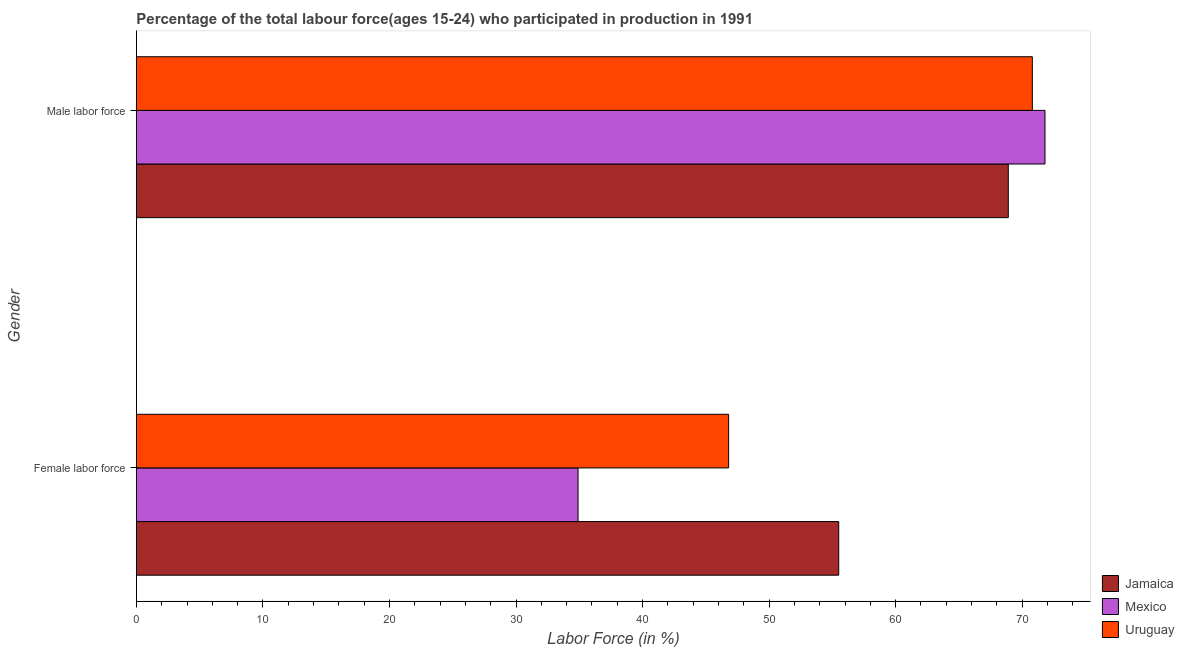Are the number of bars per tick equal to the number of legend labels?
Offer a very short reply. Yes. Are the number of bars on each tick of the Y-axis equal?
Your response must be concise. Yes. What is the label of the 2nd group of bars from the top?
Offer a terse response. Female labor force. What is the percentage of female labor force in Jamaica?
Provide a succinct answer. 55.5. Across all countries, what is the maximum percentage of female labor force?
Provide a succinct answer. 55.5. Across all countries, what is the minimum percentage of female labor force?
Provide a succinct answer. 34.9. In which country was the percentage of male labour force maximum?
Your answer should be very brief. Mexico. What is the total percentage of male labour force in the graph?
Your answer should be compact. 211.5. What is the difference between the percentage of female labor force in Mexico and that in Uruguay?
Your answer should be very brief. -11.9. What is the difference between the percentage of female labor force in Jamaica and the percentage of male labour force in Mexico?
Provide a short and direct response. -16.3. What is the average percentage of female labor force per country?
Provide a short and direct response. 45.73. What is the difference between the percentage of female labor force and percentage of male labour force in Mexico?
Provide a succinct answer. -36.9. What is the ratio of the percentage of male labour force in Uruguay to that in Jamaica?
Provide a succinct answer. 1.03. Is the percentage of male labour force in Uruguay less than that in Mexico?
Provide a succinct answer. Yes. What does the 1st bar from the bottom in Female labor force represents?
Your answer should be compact. Jamaica. Are all the bars in the graph horizontal?
Offer a very short reply. Yes. What is the difference between two consecutive major ticks on the X-axis?
Keep it short and to the point. 10. Are the values on the major ticks of X-axis written in scientific E-notation?
Provide a succinct answer. No. Does the graph contain any zero values?
Make the answer very short. No. Where does the legend appear in the graph?
Your response must be concise. Bottom right. What is the title of the graph?
Give a very brief answer. Percentage of the total labour force(ages 15-24) who participated in production in 1991. Does "Tunisia" appear as one of the legend labels in the graph?
Provide a short and direct response. No. What is the label or title of the Y-axis?
Keep it short and to the point. Gender. What is the Labor Force (in %) of Jamaica in Female labor force?
Provide a short and direct response. 55.5. What is the Labor Force (in %) in Mexico in Female labor force?
Provide a short and direct response. 34.9. What is the Labor Force (in %) in Uruguay in Female labor force?
Offer a terse response. 46.8. What is the Labor Force (in %) of Jamaica in Male labor force?
Offer a very short reply. 68.9. What is the Labor Force (in %) of Mexico in Male labor force?
Offer a very short reply. 71.8. What is the Labor Force (in %) in Uruguay in Male labor force?
Provide a succinct answer. 70.8. Across all Gender, what is the maximum Labor Force (in %) of Jamaica?
Ensure brevity in your answer.  68.9. Across all Gender, what is the maximum Labor Force (in %) of Mexico?
Make the answer very short. 71.8. Across all Gender, what is the maximum Labor Force (in %) of Uruguay?
Ensure brevity in your answer.  70.8. Across all Gender, what is the minimum Labor Force (in %) in Jamaica?
Ensure brevity in your answer.  55.5. Across all Gender, what is the minimum Labor Force (in %) of Mexico?
Offer a terse response. 34.9. Across all Gender, what is the minimum Labor Force (in %) in Uruguay?
Your answer should be compact. 46.8. What is the total Labor Force (in %) of Jamaica in the graph?
Provide a succinct answer. 124.4. What is the total Labor Force (in %) in Mexico in the graph?
Provide a short and direct response. 106.7. What is the total Labor Force (in %) in Uruguay in the graph?
Provide a succinct answer. 117.6. What is the difference between the Labor Force (in %) of Mexico in Female labor force and that in Male labor force?
Give a very brief answer. -36.9. What is the difference between the Labor Force (in %) of Uruguay in Female labor force and that in Male labor force?
Provide a short and direct response. -24. What is the difference between the Labor Force (in %) of Jamaica in Female labor force and the Labor Force (in %) of Mexico in Male labor force?
Give a very brief answer. -16.3. What is the difference between the Labor Force (in %) in Jamaica in Female labor force and the Labor Force (in %) in Uruguay in Male labor force?
Provide a succinct answer. -15.3. What is the difference between the Labor Force (in %) of Mexico in Female labor force and the Labor Force (in %) of Uruguay in Male labor force?
Offer a terse response. -35.9. What is the average Labor Force (in %) in Jamaica per Gender?
Provide a short and direct response. 62.2. What is the average Labor Force (in %) in Mexico per Gender?
Offer a terse response. 53.35. What is the average Labor Force (in %) of Uruguay per Gender?
Make the answer very short. 58.8. What is the difference between the Labor Force (in %) of Jamaica and Labor Force (in %) of Mexico in Female labor force?
Ensure brevity in your answer.  20.6. What is the difference between the Labor Force (in %) of Jamaica and Labor Force (in %) of Uruguay in Female labor force?
Make the answer very short. 8.7. What is the difference between the Labor Force (in %) of Jamaica and Labor Force (in %) of Uruguay in Male labor force?
Keep it short and to the point. -1.9. What is the ratio of the Labor Force (in %) in Jamaica in Female labor force to that in Male labor force?
Your answer should be very brief. 0.81. What is the ratio of the Labor Force (in %) of Mexico in Female labor force to that in Male labor force?
Your answer should be very brief. 0.49. What is the ratio of the Labor Force (in %) in Uruguay in Female labor force to that in Male labor force?
Provide a succinct answer. 0.66. What is the difference between the highest and the second highest Labor Force (in %) in Mexico?
Provide a succinct answer. 36.9. What is the difference between the highest and the second highest Labor Force (in %) of Uruguay?
Your answer should be very brief. 24. What is the difference between the highest and the lowest Labor Force (in %) of Jamaica?
Your response must be concise. 13.4. What is the difference between the highest and the lowest Labor Force (in %) in Mexico?
Ensure brevity in your answer.  36.9. What is the difference between the highest and the lowest Labor Force (in %) in Uruguay?
Offer a very short reply. 24. 